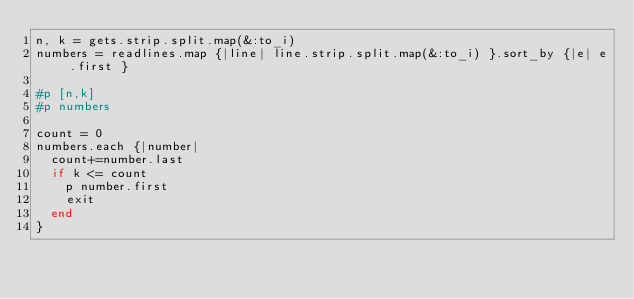<code> <loc_0><loc_0><loc_500><loc_500><_Ruby_>n, k = gets.strip.split.map(&:to_i)
numbers = readlines.map {|line| line.strip.split.map(&:to_i) }.sort_by {|e| e.first }

#p [n,k]
#p numbers

count = 0
numbers.each {|number|
  count+=number.last
  if k <= count
    p number.first
    exit
  end
}</code> 